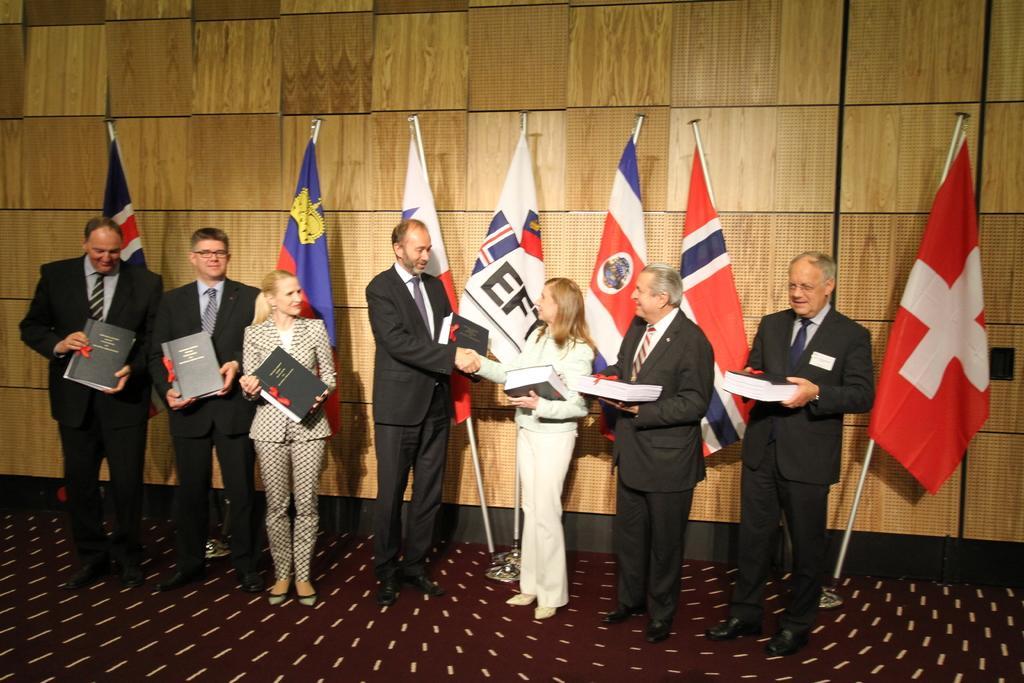Please provide a concise description of this image. Here in this picture we can see a group of people standing on the floor and holding books in their hands and we can see all the men are wearing suits and all of them are smiling and some of them are wearing spectacles and behind them we can see number of different flag posts present. 